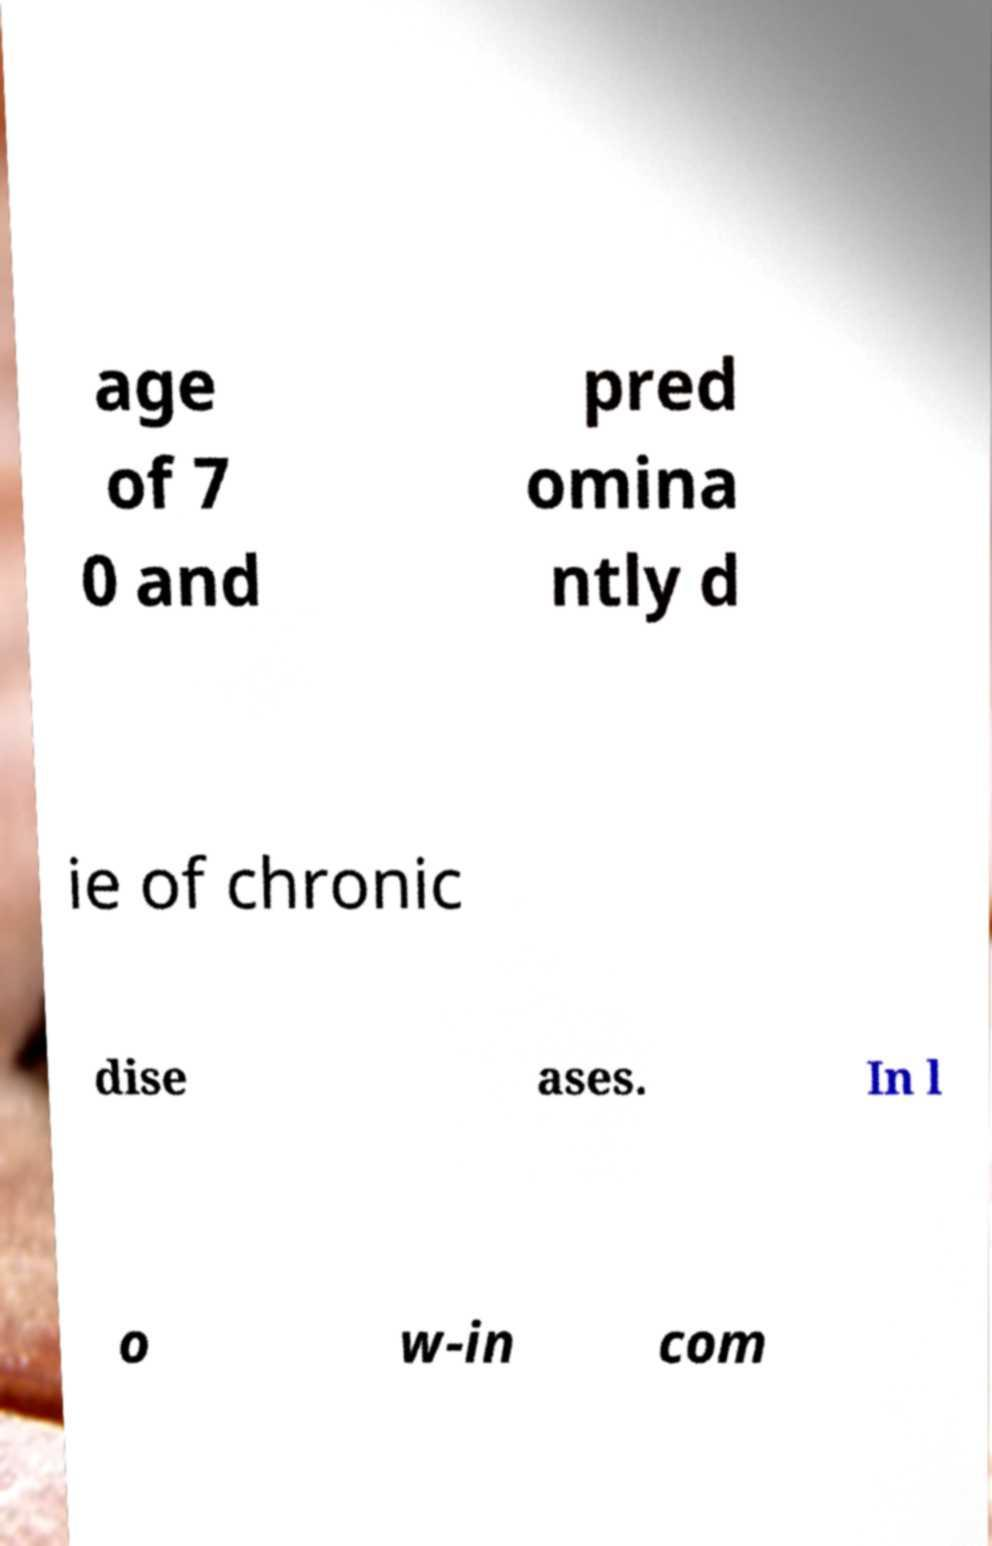There's text embedded in this image that I need extracted. Can you transcribe it verbatim? age of 7 0 and pred omina ntly d ie of chronic dise ases. In l o w-in com 